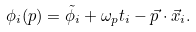<formula> <loc_0><loc_0><loc_500><loc_500>\phi _ { i } ( p ) = \tilde { \phi _ { i } } + \omega _ { p } t _ { i } - \vec { p } \cdot \vec { x } _ { i } .</formula> 